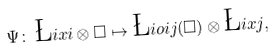<formula> <loc_0><loc_0><loc_500><loc_500>\Psi \colon \, \L i x { i } \otimes \Box \mapsto \L i o { i } { j } ( \Box ) \otimes \L i x { j } ,</formula> 